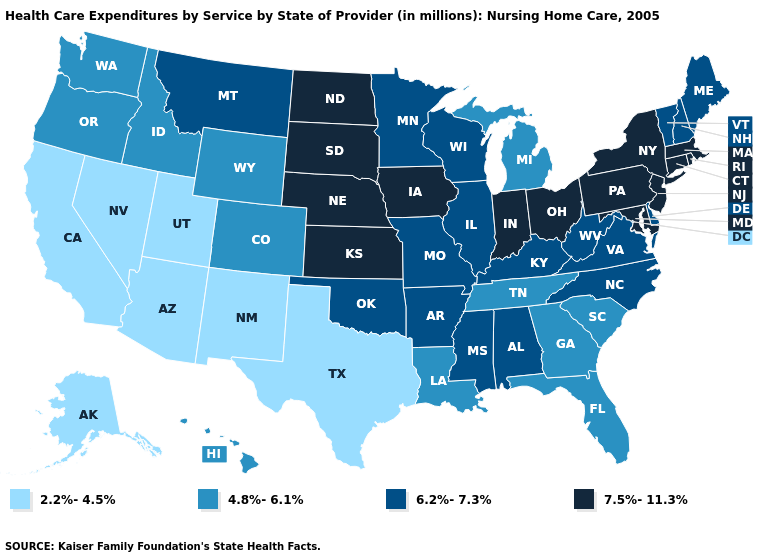Does New Mexico have a lower value than California?
Give a very brief answer. No. Name the states that have a value in the range 2.2%-4.5%?
Write a very short answer. Alaska, Arizona, California, Nevada, New Mexico, Texas, Utah. Does Maine have a higher value than Montana?
Quick response, please. No. Does Nebraska have the highest value in the USA?
Answer briefly. Yes. Which states have the highest value in the USA?
Give a very brief answer. Connecticut, Indiana, Iowa, Kansas, Maryland, Massachusetts, Nebraska, New Jersey, New York, North Dakota, Ohio, Pennsylvania, Rhode Island, South Dakota. Name the states that have a value in the range 6.2%-7.3%?
Keep it brief. Alabama, Arkansas, Delaware, Illinois, Kentucky, Maine, Minnesota, Mississippi, Missouri, Montana, New Hampshire, North Carolina, Oklahoma, Vermont, Virginia, West Virginia, Wisconsin. What is the value of South Dakota?
Keep it brief. 7.5%-11.3%. Does New Hampshire have the same value as Illinois?
Answer briefly. Yes. Which states have the highest value in the USA?
Answer briefly. Connecticut, Indiana, Iowa, Kansas, Maryland, Massachusetts, Nebraska, New Jersey, New York, North Dakota, Ohio, Pennsylvania, Rhode Island, South Dakota. Does Illinois have a lower value than Iowa?
Keep it brief. Yes. Among the states that border Nevada , does Oregon have the lowest value?
Keep it brief. No. Does Wisconsin have the lowest value in the MidWest?
Keep it brief. No. What is the value of Washington?
Give a very brief answer. 4.8%-6.1%. What is the lowest value in the USA?
Concise answer only. 2.2%-4.5%. Name the states that have a value in the range 4.8%-6.1%?
Keep it brief. Colorado, Florida, Georgia, Hawaii, Idaho, Louisiana, Michigan, Oregon, South Carolina, Tennessee, Washington, Wyoming. 